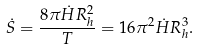Convert formula to latex. <formula><loc_0><loc_0><loc_500><loc_500>\dot { S } = \frac { 8 \pi \dot { H } R _ { h } ^ { 2 } } { T } = 1 6 \pi ^ { 2 } \dot { H } R _ { h } ^ { 3 } .</formula> 